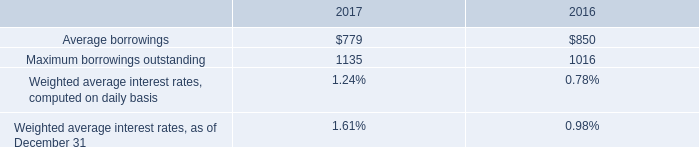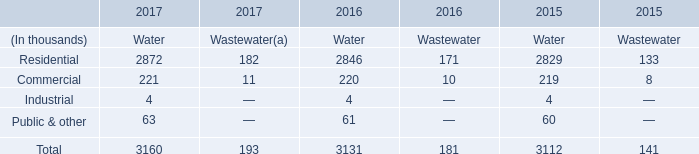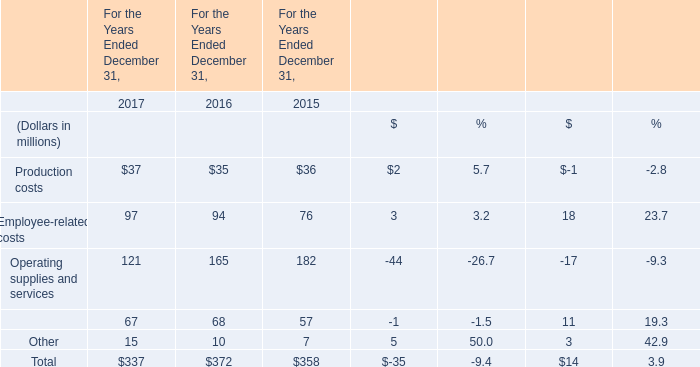What's the growth rate of Total in 2017? (in %) 
Computations: ((337 - 372) / 372)
Answer: -0.09409. 